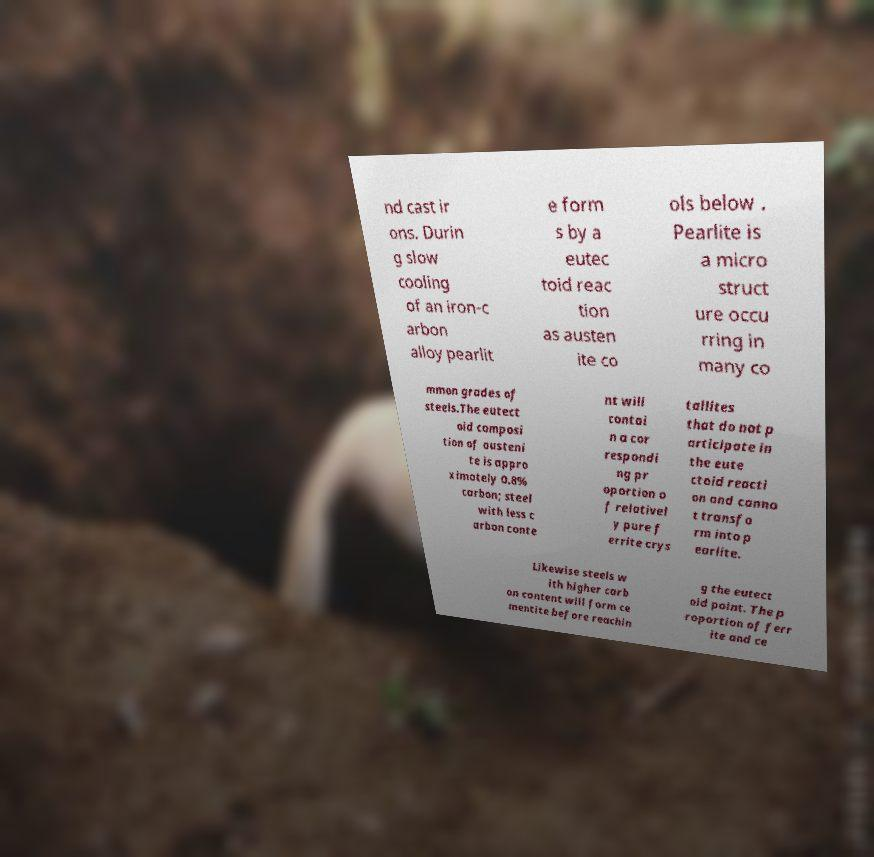Please identify and transcribe the text found in this image. nd cast ir ons. Durin g slow cooling of an iron-c arbon alloy pearlit e form s by a eutec toid reac tion as austen ite co ols below . Pearlite is a micro struct ure occu rring in many co mmon grades of steels.The eutect oid composi tion of austeni te is appro ximately 0.8% carbon; steel with less c arbon conte nt will contai n a cor respondi ng pr oportion o f relativel y pure f errite crys tallites that do not p articipate in the eute ctoid reacti on and canno t transfo rm into p earlite. Likewise steels w ith higher carb on content will form ce mentite before reachin g the eutect oid point. The p roportion of ferr ite and ce 